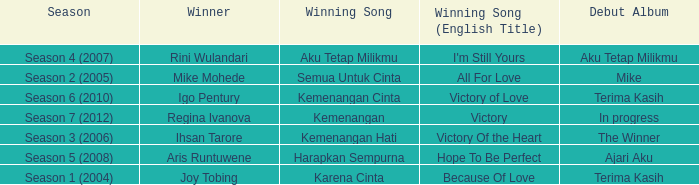Which English winning song had the winner aris runtuwene? Hope To Be Perfect. 